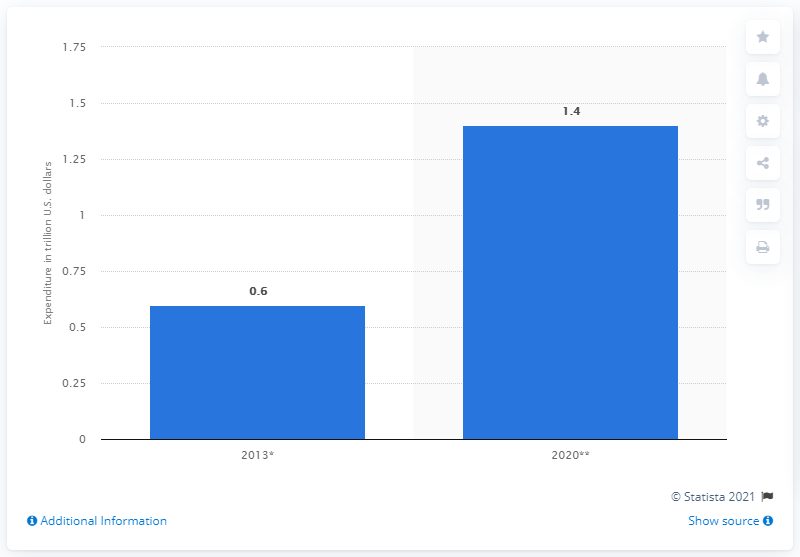Mention a couple of crucial points in this snapshot. By 2020, Millennials are projected to spend a total of 1.4 trillion dollars in the United States. 